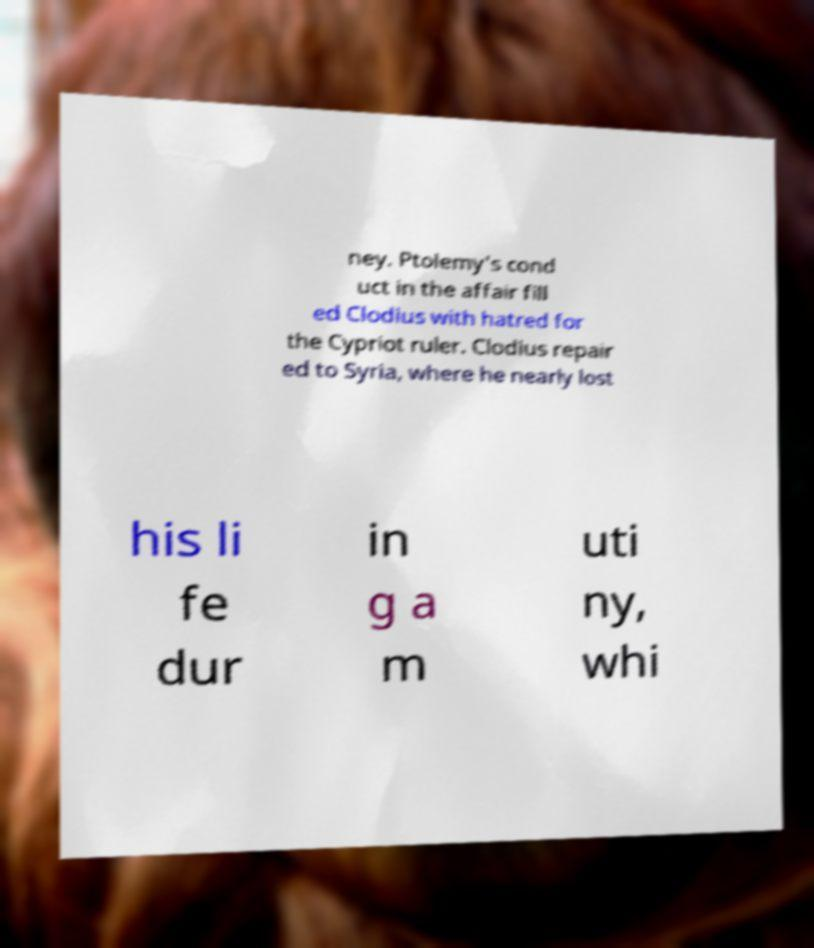I need the written content from this picture converted into text. Can you do that? ney. Ptolemy's cond uct in the affair fill ed Clodius with hatred for the Cypriot ruler. Clodius repair ed to Syria, where he nearly lost his li fe dur in g a m uti ny, whi 